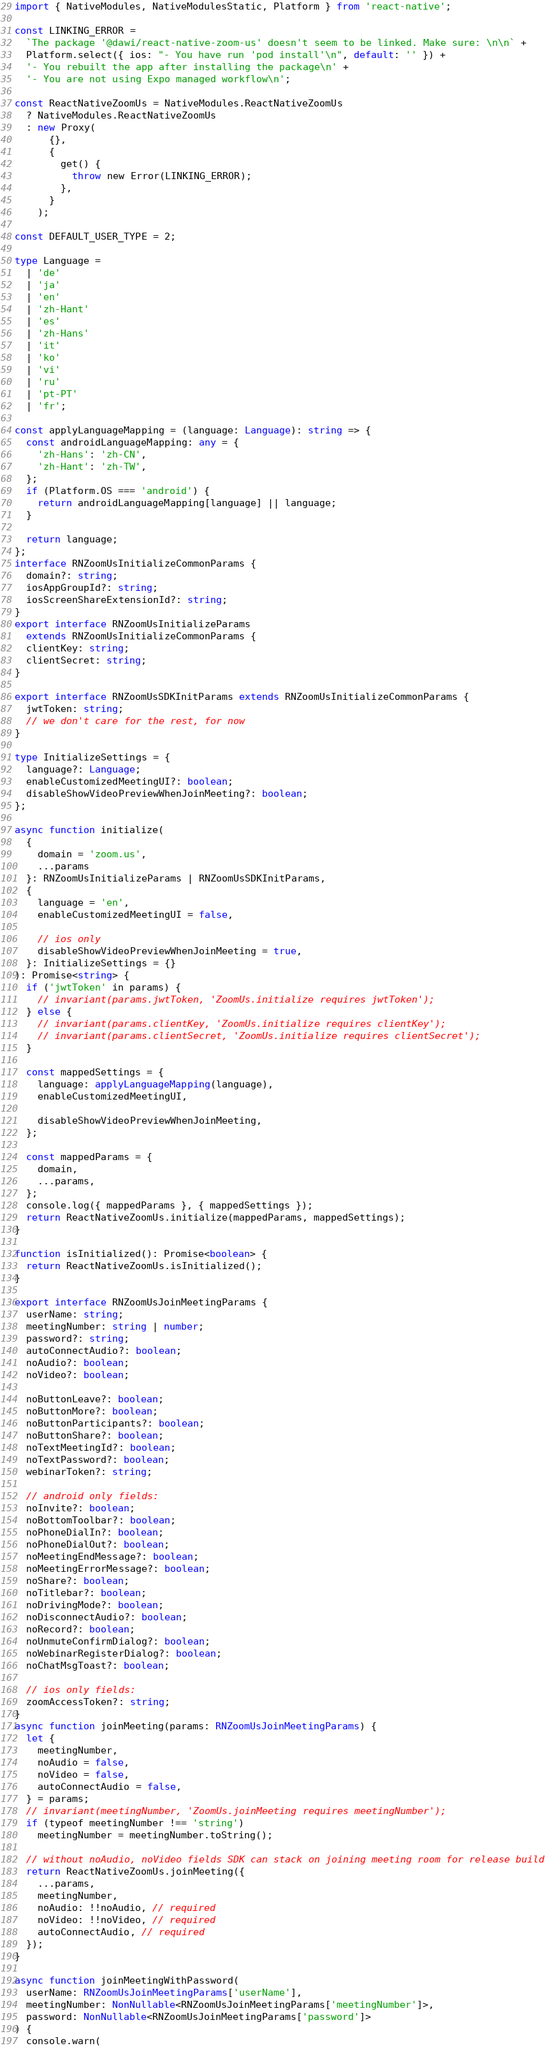Convert code to text. <code><loc_0><loc_0><loc_500><loc_500><_TypeScript_>import { NativeModules, NativeModulesStatic, Platform } from 'react-native';

const LINKING_ERROR =
  `The package '@dawi/react-native-zoom-us' doesn't seem to be linked. Make sure: \n\n` +
  Platform.select({ ios: "- You have run 'pod install'\n", default: '' }) +
  '- You rebuilt the app after installing the package\n' +
  '- You are not using Expo managed workflow\n';

const ReactNativeZoomUs = NativeModules.ReactNativeZoomUs
  ? NativeModules.ReactNativeZoomUs
  : new Proxy(
      {},
      {
        get() {
          throw new Error(LINKING_ERROR);
        },
      }
    );

const DEFAULT_USER_TYPE = 2;

type Language =
  | 'de'
  | 'ja'
  | 'en'
  | 'zh-Hant'
  | 'es'
  | 'zh-Hans'
  | 'it'
  | 'ko'
  | 'vi'
  | 'ru'
  | 'pt-PT'
  | 'fr';

const applyLanguageMapping = (language: Language): string => {
  const androidLanguageMapping: any = {
    'zh-Hans': 'zh-CN',
    'zh-Hant': 'zh-TW',
  };
  if (Platform.OS === 'android') {
    return androidLanguageMapping[language] || language;
  }

  return language;
};
interface RNZoomUsInitializeCommonParams {
  domain?: string;
  iosAppGroupId?: string;
  iosScreenShareExtensionId?: string;
}
export interface RNZoomUsInitializeParams
  extends RNZoomUsInitializeCommonParams {
  clientKey: string;
  clientSecret: string;
}

export interface RNZoomUsSDKInitParams extends RNZoomUsInitializeCommonParams {
  jwtToken: string;
  // we don't care for the rest, for now
}

type InitializeSettings = {
  language?: Language;
  enableCustomizedMeetingUI?: boolean;
  disableShowVideoPreviewWhenJoinMeeting?: boolean;
};

async function initialize(
  {
    domain = 'zoom.us',
    ...params
  }: RNZoomUsInitializeParams | RNZoomUsSDKInitParams,
  {
    language = 'en',
    enableCustomizedMeetingUI = false,

    // ios only
    disableShowVideoPreviewWhenJoinMeeting = true,
  }: InitializeSettings = {}
): Promise<string> {
  if ('jwtToken' in params) {
    // invariant(params.jwtToken, 'ZoomUs.initialize requires jwtToken');
  } else {
    // invariant(params.clientKey, 'ZoomUs.initialize requires clientKey');
    // invariant(params.clientSecret, 'ZoomUs.initialize requires clientSecret');
  }

  const mappedSettings = {
    language: applyLanguageMapping(language),
    enableCustomizedMeetingUI,

    disableShowVideoPreviewWhenJoinMeeting,
  };

  const mappedParams = {
    domain,
    ...params,
  };
  console.log({ mappedParams }, { mappedSettings });
  return ReactNativeZoomUs.initialize(mappedParams, mappedSettings);
}

function isInitialized(): Promise<boolean> {
  return ReactNativeZoomUs.isInitialized();
}

export interface RNZoomUsJoinMeetingParams {
  userName: string;
  meetingNumber: string | number;
  password?: string;
  autoConnectAudio?: boolean;
  noAudio?: boolean;
  noVideo?: boolean;

  noButtonLeave?: boolean;
  noButtonMore?: boolean;
  noButtonParticipants?: boolean;
  noButtonShare?: boolean;
  noTextMeetingId?: boolean;
  noTextPassword?: boolean;
  webinarToken?: string;

  // android only fields:
  noInvite?: boolean;
  noBottomToolbar?: boolean;
  noPhoneDialIn?: boolean;
  noPhoneDialOut?: boolean;
  noMeetingEndMessage?: boolean;
  noMeetingErrorMessage?: boolean;
  noShare?: boolean;
  noTitlebar?: boolean;
  noDrivingMode?: boolean;
  noDisconnectAudio?: boolean;
  noRecord?: boolean;
  noUnmuteConfirmDialog?: boolean;
  noWebinarRegisterDialog?: boolean;
  noChatMsgToast?: boolean;

  // ios only fields:
  zoomAccessToken?: string;
}
async function joinMeeting(params: RNZoomUsJoinMeetingParams) {
  let {
    meetingNumber,
    noAudio = false,
    noVideo = false,
    autoConnectAudio = false,
  } = params;
  // invariant(meetingNumber, 'ZoomUs.joinMeeting requires meetingNumber');
  if (typeof meetingNumber !== 'string')
    meetingNumber = meetingNumber.toString();

  // without noAudio, noVideo fields SDK can stack on joining meeting room for release build
  return ReactNativeZoomUs.joinMeeting({
    ...params,
    meetingNumber,
    noAudio: !!noAudio, // required
    noVideo: !!noVideo, // required
    autoConnectAudio, // required
  });
}

async function joinMeetingWithPassword(
  userName: RNZoomUsJoinMeetingParams['userName'],
  meetingNumber: NonNullable<RNZoomUsJoinMeetingParams['meetingNumber']>,
  password: NonNullable<RNZoomUsJoinMeetingParams['password']>
) {
  console.warn(</code> 